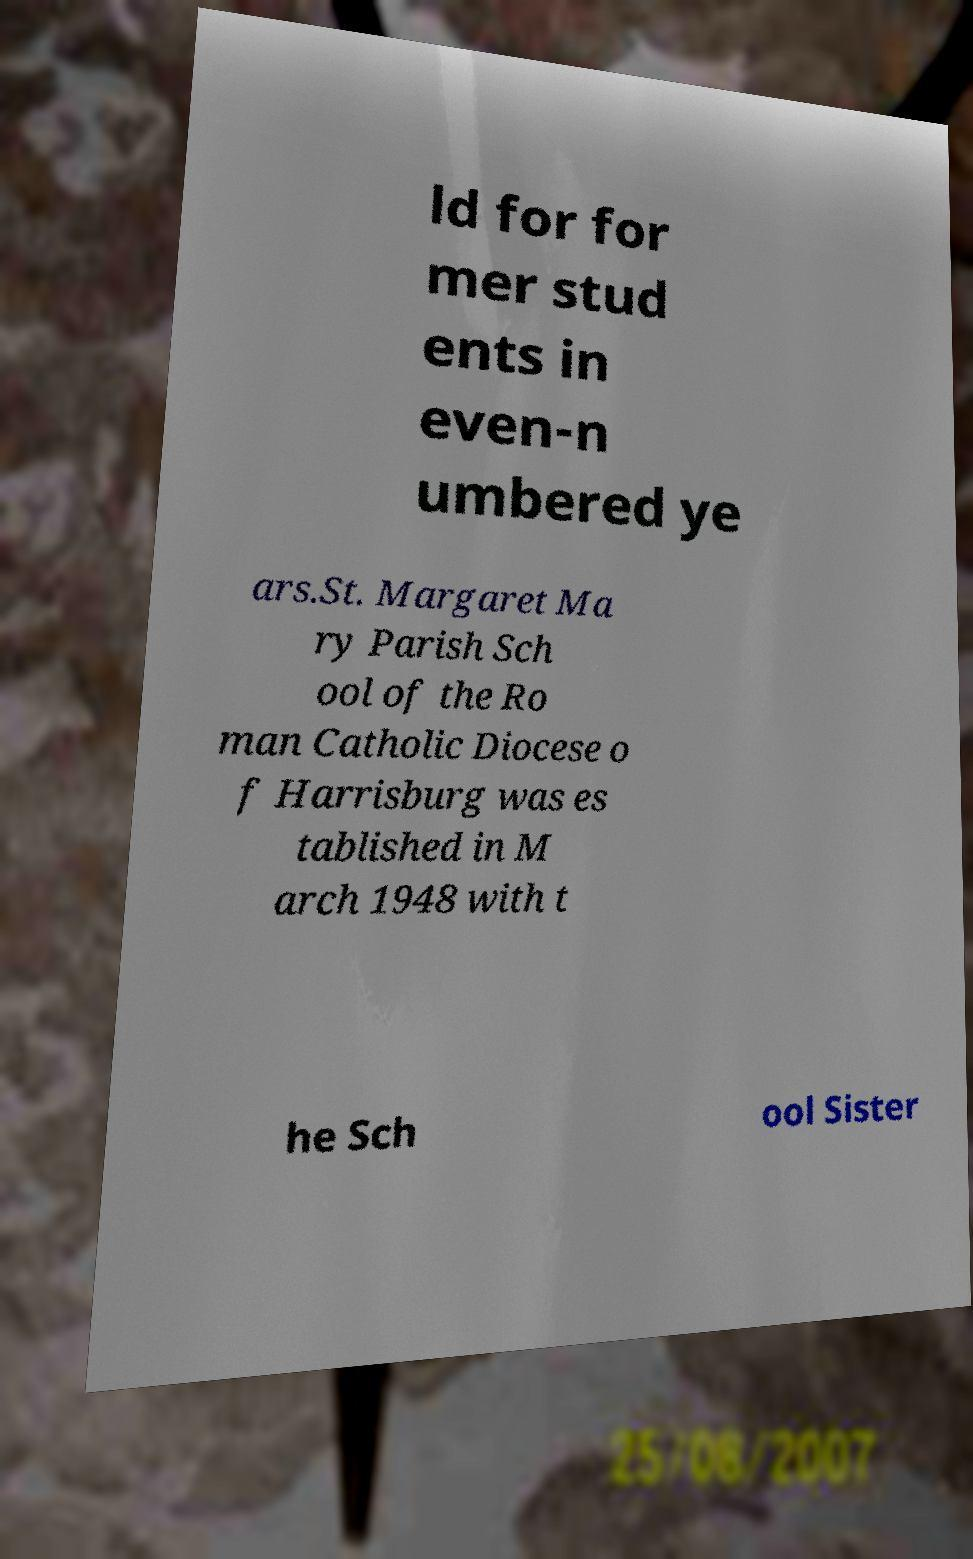There's text embedded in this image that I need extracted. Can you transcribe it verbatim? ld for for mer stud ents in even-n umbered ye ars.St. Margaret Ma ry Parish Sch ool of the Ro man Catholic Diocese o f Harrisburg was es tablished in M arch 1948 with t he Sch ool Sister 